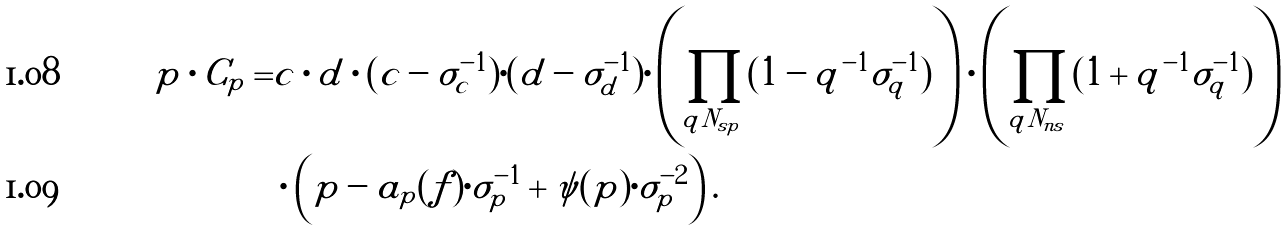<formula> <loc_0><loc_0><loc_500><loc_500>p \cdot C _ { p } = & c \cdot d \cdot ( c - \sigma ^ { - 1 } _ { c } ) \cdot ( d - \sigma ^ { - 1 } _ { d } ) \cdot \left ( \prod _ { q | N _ { s p } } ( 1 - q ^ { - 1 } \sigma ^ { - 1 } _ { q } ) \right ) \cdot \left ( \prod _ { q | N _ { n s } } ( 1 + q ^ { - 1 } \sigma ^ { - 1 } _ { q } ) \right ) \\ & \cdot \left ( p - a _ { p } ( f ) \cdot \sigma ^ { - 1 } _ { p } + \psi ( p ) \cdot \sigma ^ { - 2 } _ { p } \right ) .</formula> 